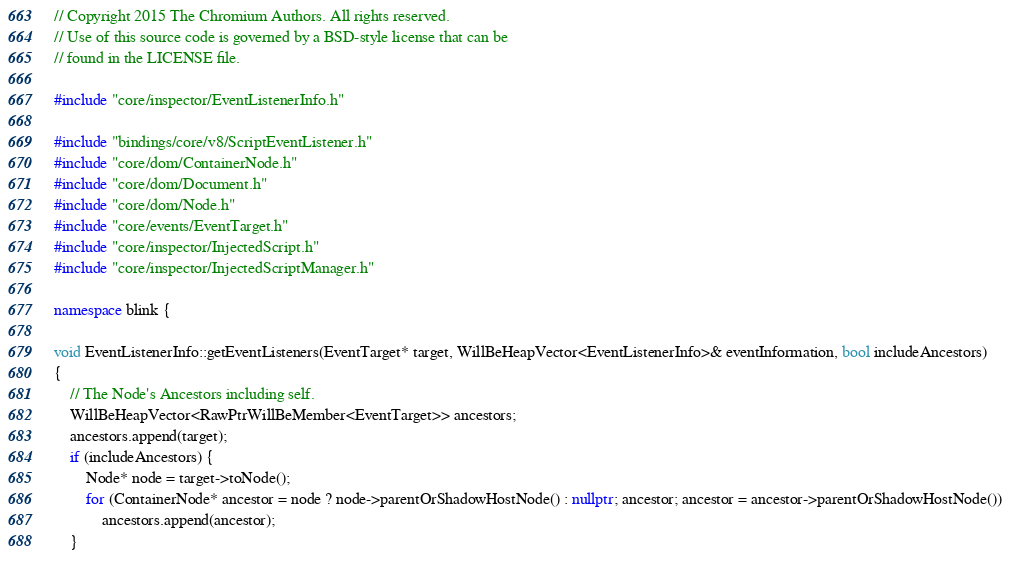<code> <loc_0><loc_0><loc_500><loc_500><_C++_>// Copyright 2015 The Chromium Authors. All rights reserved.
// Use of this source code is governed by a BSD-style license that can be
// found in the LICENSE file.

#include "core/inspector/EventListenerInfo.h"

#include "bindings/core/v8/ScriptEventListener.h"
#include "core/dom/ContainerNode.h"
#include "core/dom/Document.h"
#include "core/dom/Node.h"
#include "core/events/EventTarget.h"
#include "core/inspector/InjectedScript.h"
#include "core/inspector/InjectedScriptManager.h"

namespace blink {

void EventListenerInfo::getEventListeners(EventTarget* target, WillBeHeapVector<EventListenerInfo>& eventInformation, bool includeAncestors)
{
    // The Node's Ancestors including self.
    WillBeHeapVector<RawPtrWillBeMember<EventTarget>> ancestors;
    ancestors.append(target);
    if (includeAncestors) {
        Node* node = target->toNode();
        for (ContainerNode* ancestor = node ? node->parentOrShadowHostNode() : nullptr; ancestor; ancestor = ancestor->parentOrShadowHostNode())
            ancestors.append(ancestor);
    }
</code> 